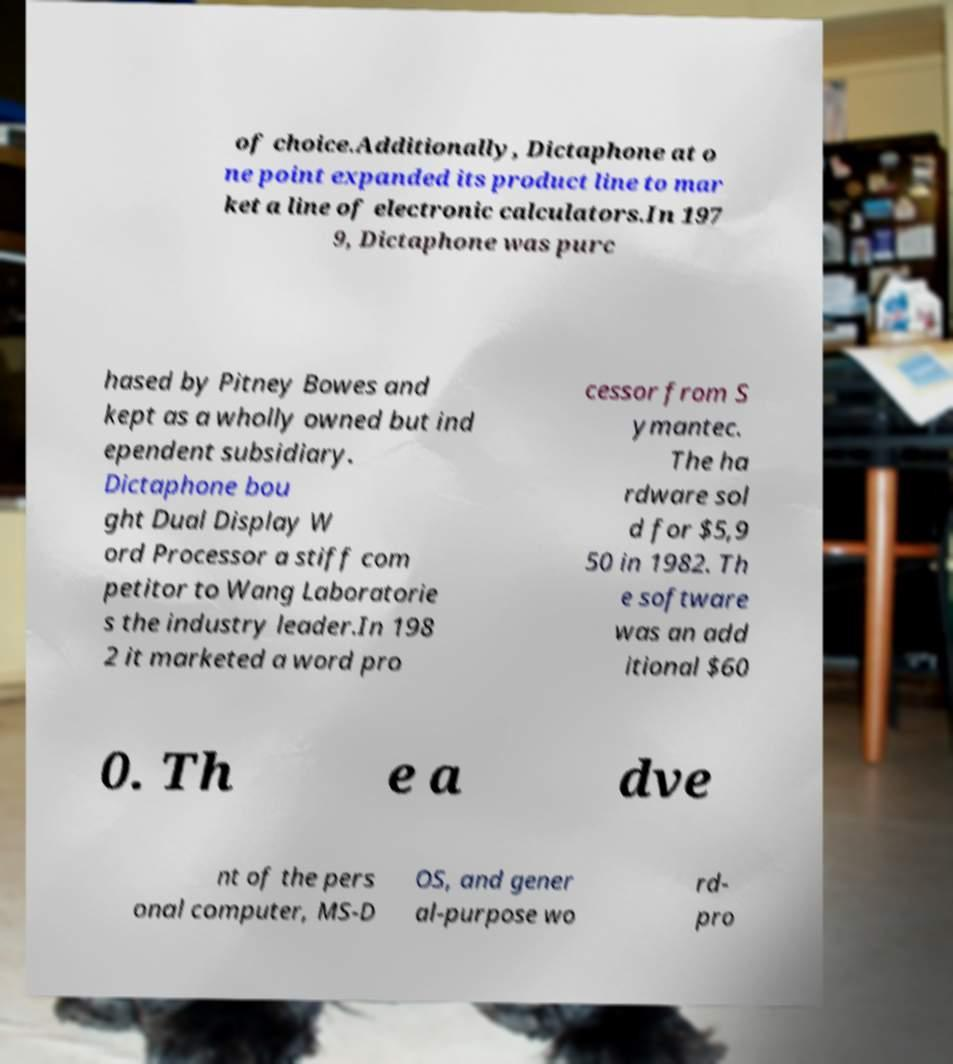Please identify and transcribe the text found in this image. of choice.Additionally, Dictaphone at o ne point expanded its product line to mar ket a line of electronic calculators.In 197 9, Dictaphone was purc hased by Pitney Bowes and kept as a wholly owned but ind ependent subsidiary. Dictaphone bou ght Dual Display W ord Processor a stiff com petitor to Wang Laboratorie s the industry leader.In 198 2 it marketed a word pro cessor from S ymantec. The ha rdware sol d for $5,9 50 in 1982. Th e software was an add itional $60 0. Th e a dve nt of the pers onal computer, MS-D OS, and gener al-purpose wo rd- pro 